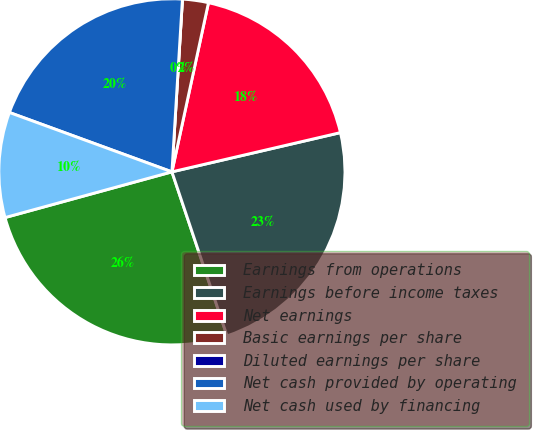Convert chart. <chart><loc_0><loc_0><loc_500><loc_500><pie_chart><fcel>Earnings from operations<fcel>Earnings before income taxes<fcel>Net earnings<fcel>Basic earnings per share<fcel>Diluted earnings per share<fcel>Net cash provided by operating<fcel>Net cash used by financing<nl><fcel>25.9%<fcel>23.48%<fcel>17.97%<fcel>2.42%<fcel>0.0%<fcel>20.39%<fcel>9.83%<nl></chart> 